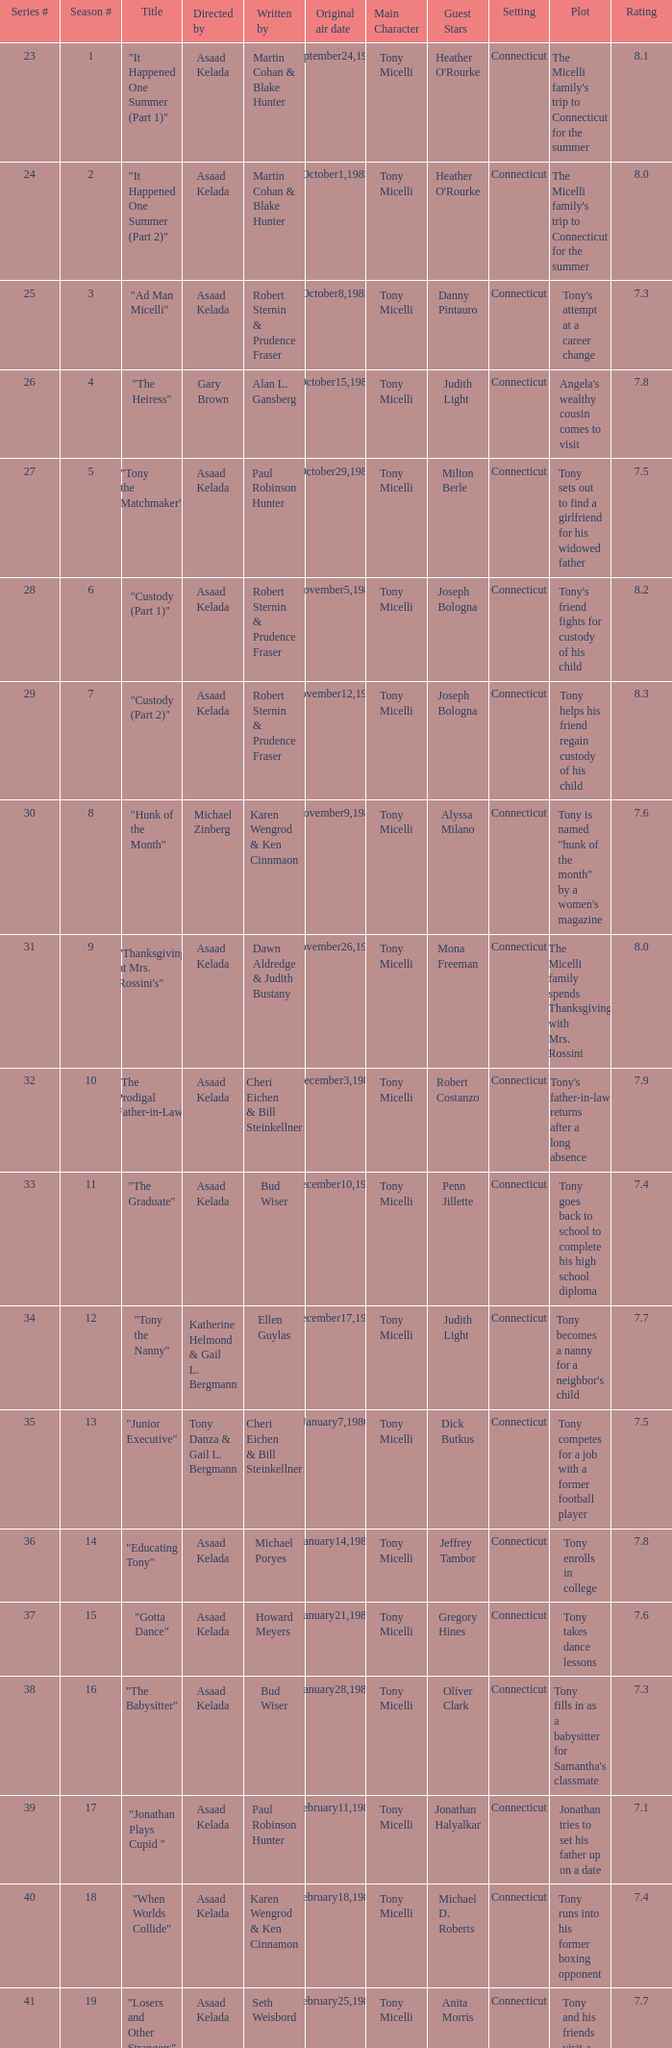Who were the authors of series episode #25? Robert Sternin & Prudence Fraser. 